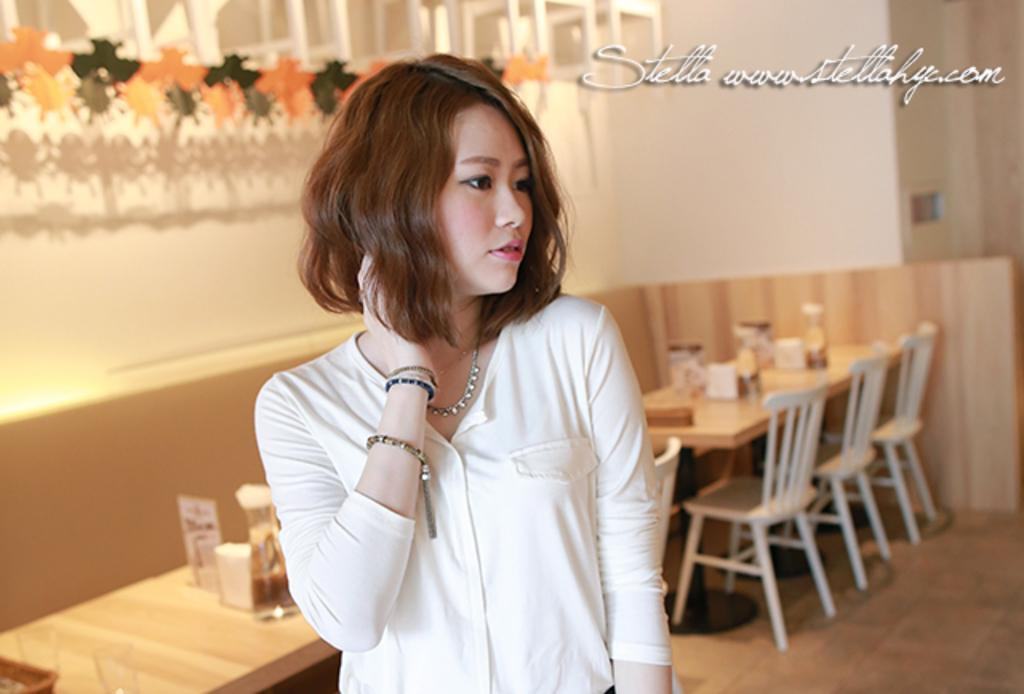Who is present in the image? There is a girl in the image. What is the girl wearing? The girl is wearing a white shirt. Where is the girl located? The girl is standing in a room. What objects can be seen on the table? There are glasses, bottles, and tissues on the table. What furniture is visible in the room? There are chairs at the back side of the room. How does the girl provide comfort to the tramp in the image? There is no tramp present in the image, so the girl cannot provide comfort to one. 